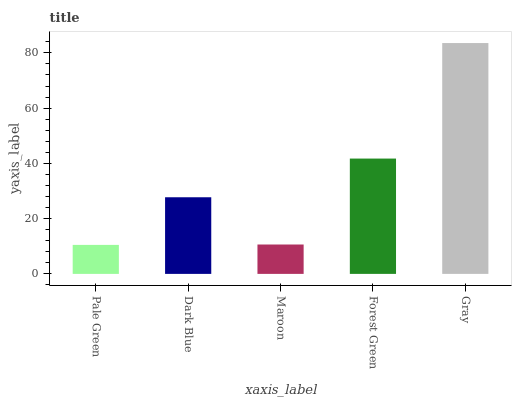Is Dark Blue the minimum?
Answer yes or no. No. Is Dark Blue the maximum?
Answer yes or no. No. Is Dark Blue greater than Pale Green?
Answer yes or no. Yes. Is Pale Green less than Dark Blue?
Answer yes or no. Yes. Is Pale Green greater than Dark Blue?
Answer yes or no. No. Is Dark Blue less than Pale Green?
Answer yes or no. No. Is Dark Blue the high median?
Answer yes or no. Yes. Is Dark Blue the low median?
Answer yes or no. Yes. Is Maroon the high median?
Answer yes or no. No. Is Forest Green the low median?
Answer yes or no. No. 